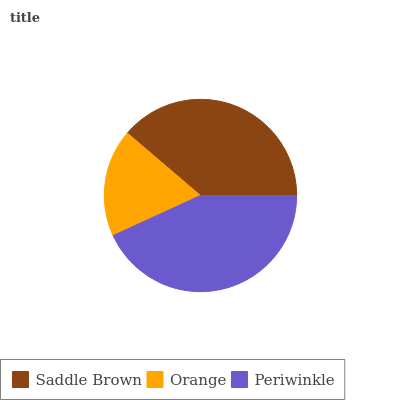Is Orange the minimum?
Answer yes or no. Yes. Is Periwinkle the maximum?
Answer yes or no. Yes. Is Periwinkle the minimum?
Answer yes or no. No. Is Orange the maximum?
Answer yes or no. No. Is Periwinkle greater than Orange?
Answer yes or no. Yes. Is Orange less than Periwinkle?
Answer yes or no. Yes. Is Orange greater than Periwinkle?
Answer yes or no. No. Is Periwinkle less than Orange?
Answer yes or no. No. Is Saddle Brown the high median?
Answer yes or no. Yes. Is Saddle Brown the low median?
Answer yes or no. Yes. Is Orange the high median?
Answer yes or no. No. Is Orange the low median?
Answer yes or no. No. 